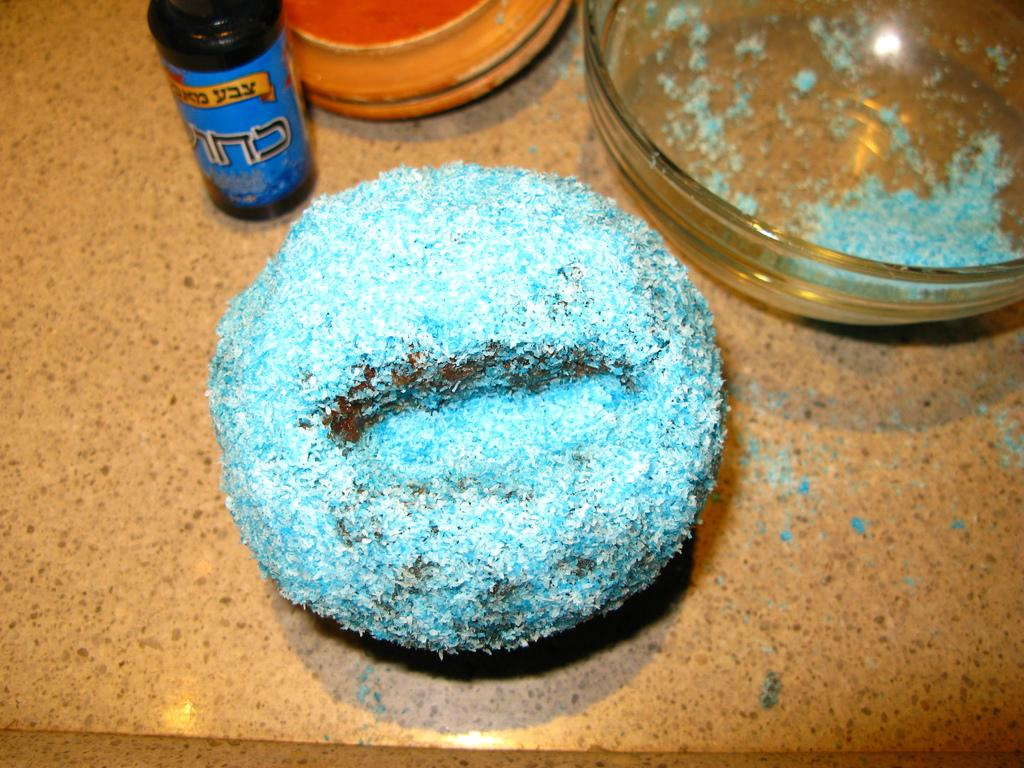What is the main subject of the image? There is a dessert in the center of the image. What type of containers are present in the image? There are bowls in the image. What other object can be seen on the table in the image? There is a bottle on the table in the image. What type of toy is hidden under the dessert in the image? There is no toy present in the image; it only features a dessert, bowls, and a bottle. 